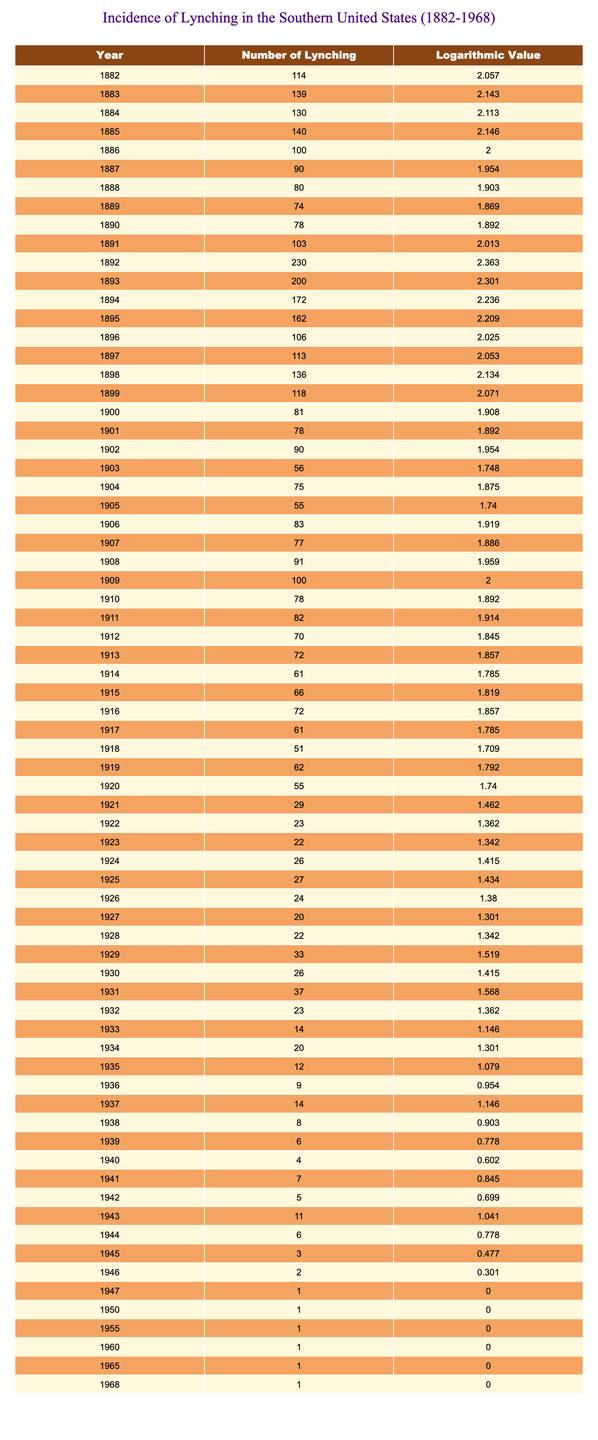What was the year with the highest number of lynchings? By looking through the "Number of Lynching" column, I identify that the highest value is 230, which corresponds to the year 1892.
Answer: 1892 What is the logarithmic value for the year 1900? The table shows that for the year 1900, the logarithmic value is listed as 1.908.
Answer: 1.908 How many lynchings were recorded in 1930? According to the table, the number of lynchings for the year 1930 is 26.
Answer: 26 What was the average number of lynchings from 1940 to 1945? I will sum the lynchings for the years 1940 (4), 1941 (7), 1942 (5), 1943 (11), 1944 (6), and 1945 (3). This gives a total of 36. There are 6 data points, so the average is 36/6 = 6.
Answer: 6 Is the year 1921 associated with more than 30 lynchings? The table shows that in 1921, there were only 29 lynchings, which is less than 30.
Answer: No Which year marks the lowest recorded number of lynchings and what is that number? Scanning the "Number of Lynching" column, I see that the lowest value is 1, which occurs in the years 1947, 1950, 1955, 1960, 1965, and 1968.
Answer: 1 What was the difference in the number of lynchings between the years 1912 and 1914? The number of lynchings in 1912 is 70, while in 1914 it is 61. The difference is calculated as 70 - 61 = 9.
Answer: 9 Did the number of lynchings increase or decrease from 1882 to 1892? The number of lynchings increased from 114 in 1882 to 230 in 1892, indicating an overall rise.
Answer: Yes What was the percentage decline in lynchings from 1892 (230 lynchings) to 1946 (2 lynchings)? The number of lynchings decreased from 230 to 2, which is a decline of 228. To find the percentage decline: (228/230) * 100 = 99.13%.
Answer: 99.13% 